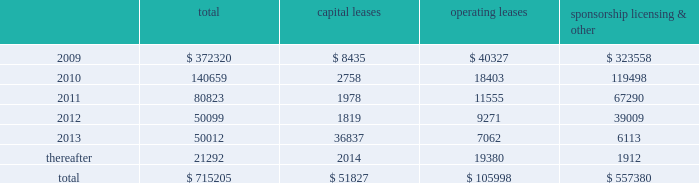Mastercard incorporated notes to consolidated financial statements 2014 ( continued ) ( in thousands , except percent and per share data ) note 17 .
Commitments at december 31 , 2008 , the company had the following future minimum payments due under non-cancelable agreements : capital leases operating leases sponsorship , licensing & .
Included in the table above are capital leases with imputed interest expense of $ 9483 and a net present value of minimum lease payments of $ 42343 .
In addition , at december 31 , 2008 , $ 92300 of the future minimum payments in the table above for leases , sponsorship , licensing and other agreements was accrued .
Consolidated rental expense for the company 2019s office space , which is recognized on a straight line basis over the life of the lease , was approximately $ 42905 , $ 35614 and $ 31467 for the years ended december 31 , 2008 , 2007 and 2006 , respectively .
Consolidated lease expense for automobiles , computer equipment and office equipment was $ 7694 , $ 7679 and $ 8419 for the years ended december 31 , 2008 , 2007 and 2006 , respectively .
In january 2003 , mastercard purchased a building in kansas city , missouri for approximately $ 23572 .
The building is a co-processing data center which replaced a back-up data center in lake success , new york .
During 2003 , mastercard entered into agreements with the city of kansas city for ( i ) the sale-leaseback of the building and related equipment which totaled $ 36382 and ( ii ) the purchase of municipal bonds for the same amount which have been classified as municipal bonds held-to-maturity .
The agreements enabled mastercard to secure state and local financial benefits .
No gain or loss was recorded in connection with the agreements .
The leaseback has been accounted for as a capital lease as the agreement contains a bargain purchase option at the end of the ten-year lease term on april 1 , 2013 .
The building and related equipment are being depreciated over their estimated economic life in accordance with the company 2019s policy .
Rent of $ 1819 is due annually and is equal to the interest due on the municipal bonds .
The future minimum lease payments are $ 45781 and are included in the table above .
A portion of the building was subleased to the original building owner for a five-year term with a renewal option .
As of december 31 , 2008 , the future minimum sublease rental income is $ 4416 .
Note 18 .
Obligations under litigation settlements on october 27 , 2008 , mastercard and visa inc .
( 201cvisa 201d ) entered into a settlement agreement ( the 201cdiscover settlement 201d ) with discover financial services , inc .
( 201cdiscover 201d ) relating to the u.s .
Federal antitrust litigation amongst the parties .
The discover settlement ended all litigation between the parties for a total of $ 2750000 .
In july 2008 , mastercard and visa had entered into a judgment sharing agreement that allocated responsibility for any judgment or settlement of the discover action between the parties .
Accordingly , the mastercard share of the discover settlement was $ 862500 , which was paid to discover in november 2008 .
In addition , in connection with the discover settlement , morgan stanley , discover 2019s former parent company , paid mastercard $ 35000 in november 2008 , pursuant to a separate agreement .
The net impact of $ 827500 is included in litigation settlements for the year ended december 31 , 2008. .
Considering the year 2011 , what is the percentage of capital leases among the total future minimum payments? 
Rationale: it is the value of capital leases divided by the total value of future minimum payments , then turned into a percentage .
Computations: (1978 / 80823)
Answer: 0.02447. 